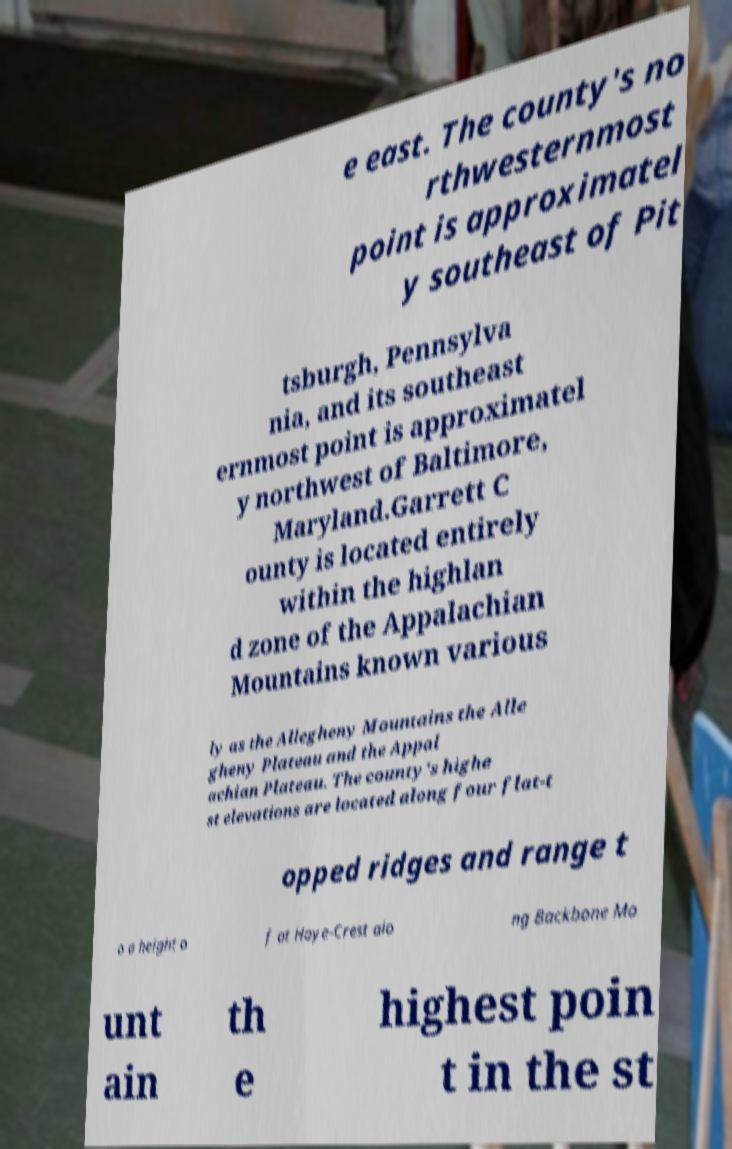I need the written content from this picture converted into text. Can you do that? e east. The county's no rthwesternmost point is approximatel y southeast of Pit tsburgh, Pennsylva nia, and its southeast ernmost point is approximatel y northwest of Baltimore, Maryland.Garrett C ounty is located entirely within the highlan d zone of the Appalachian Mountains known various ly as the Allegheny Mountains the Alle gheny Plateau and the Appal achian Plateau. The county's highe st elevations are located along four flat-t opped ridges and range t o a height o f at Hoye-Crest alo ng Backbone Mo unt ain th e highest poin t in the st 